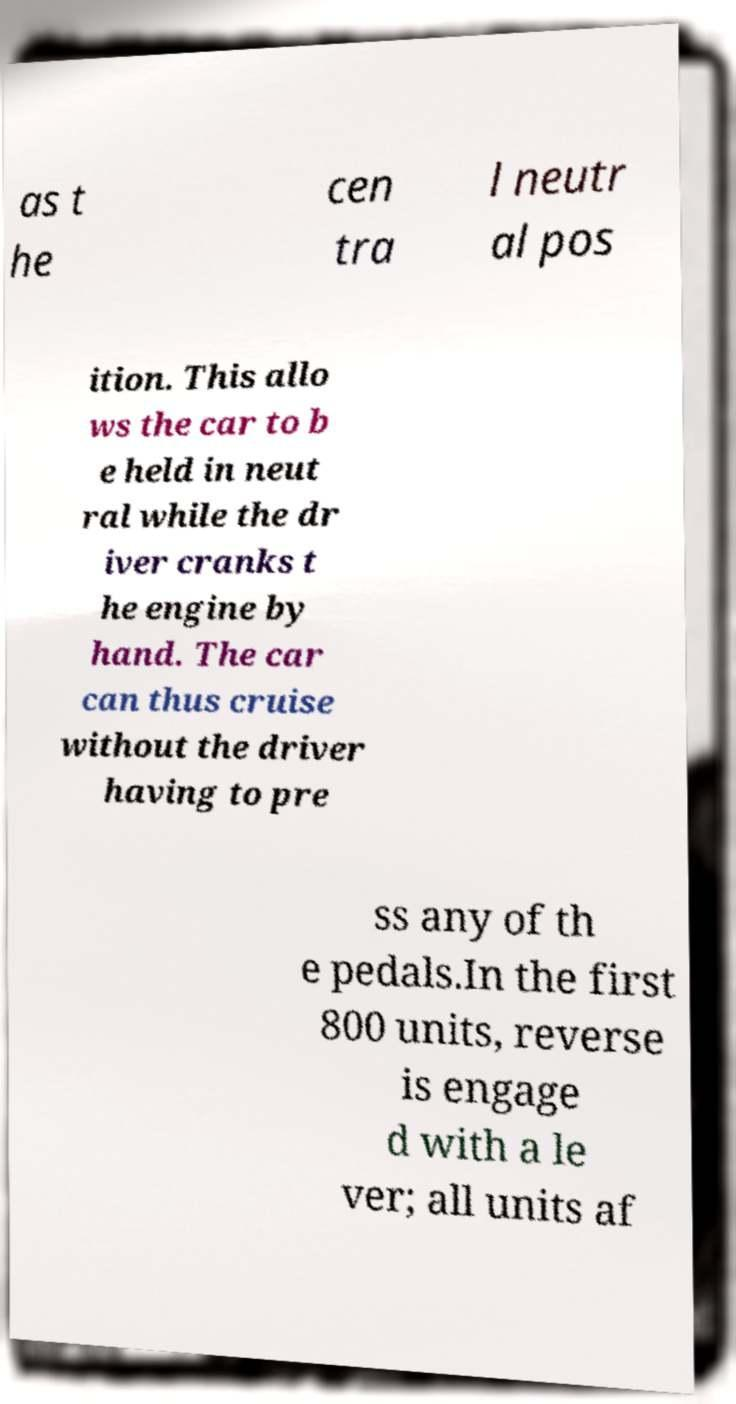Could you extract and type out the text from this image? as t he cen tra l neutr al pos ition. This allo ws the car to b e held in neut ral while the dr iver cranks t he engine by hand. The car can thus cruise without the driver having to pre ss any of th e pedals.In the first 800 units, reverse is engage d with a le ver; all units af 